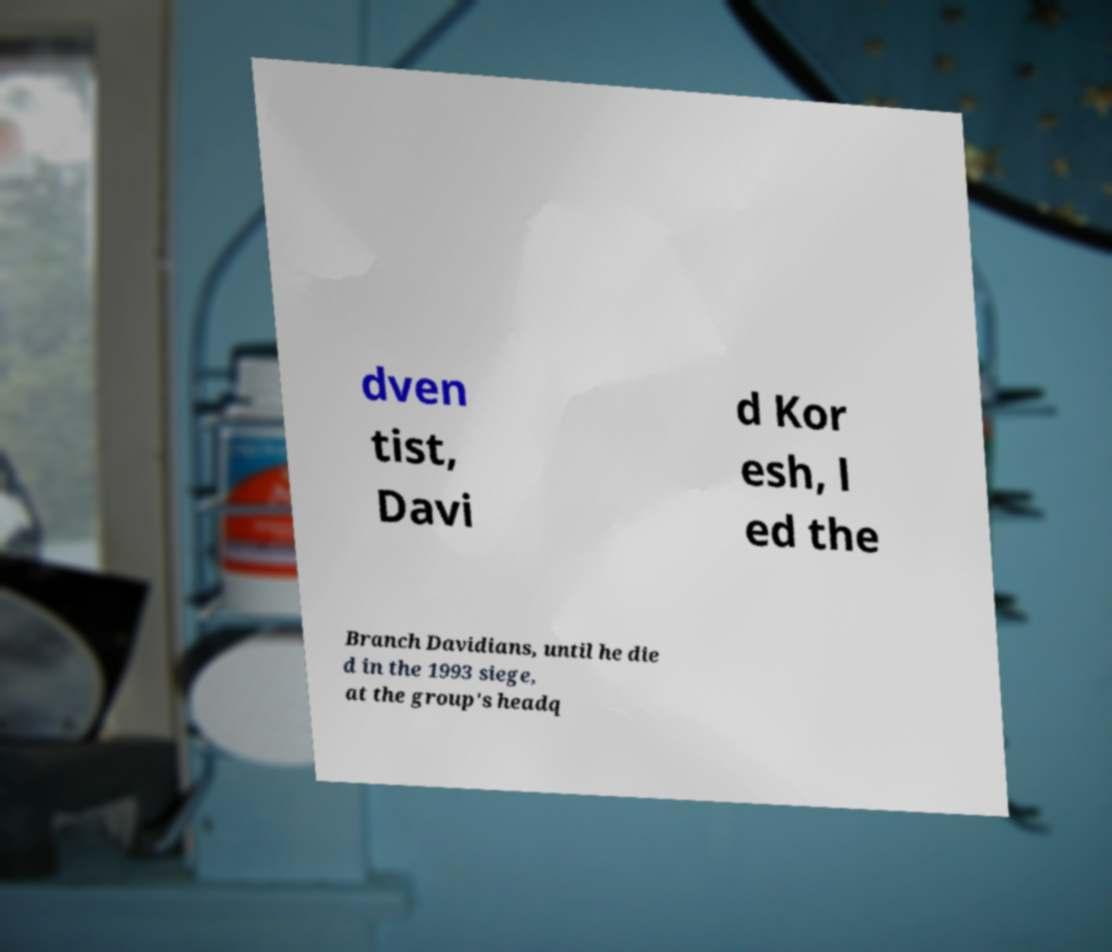There's text embedded in this image that I need extracted. Can you transcribe it verbatim? dven tist, Davi d Kor esh, l ed the Branch Davidians, until he die d in the 1993 siege, at the group's headq 